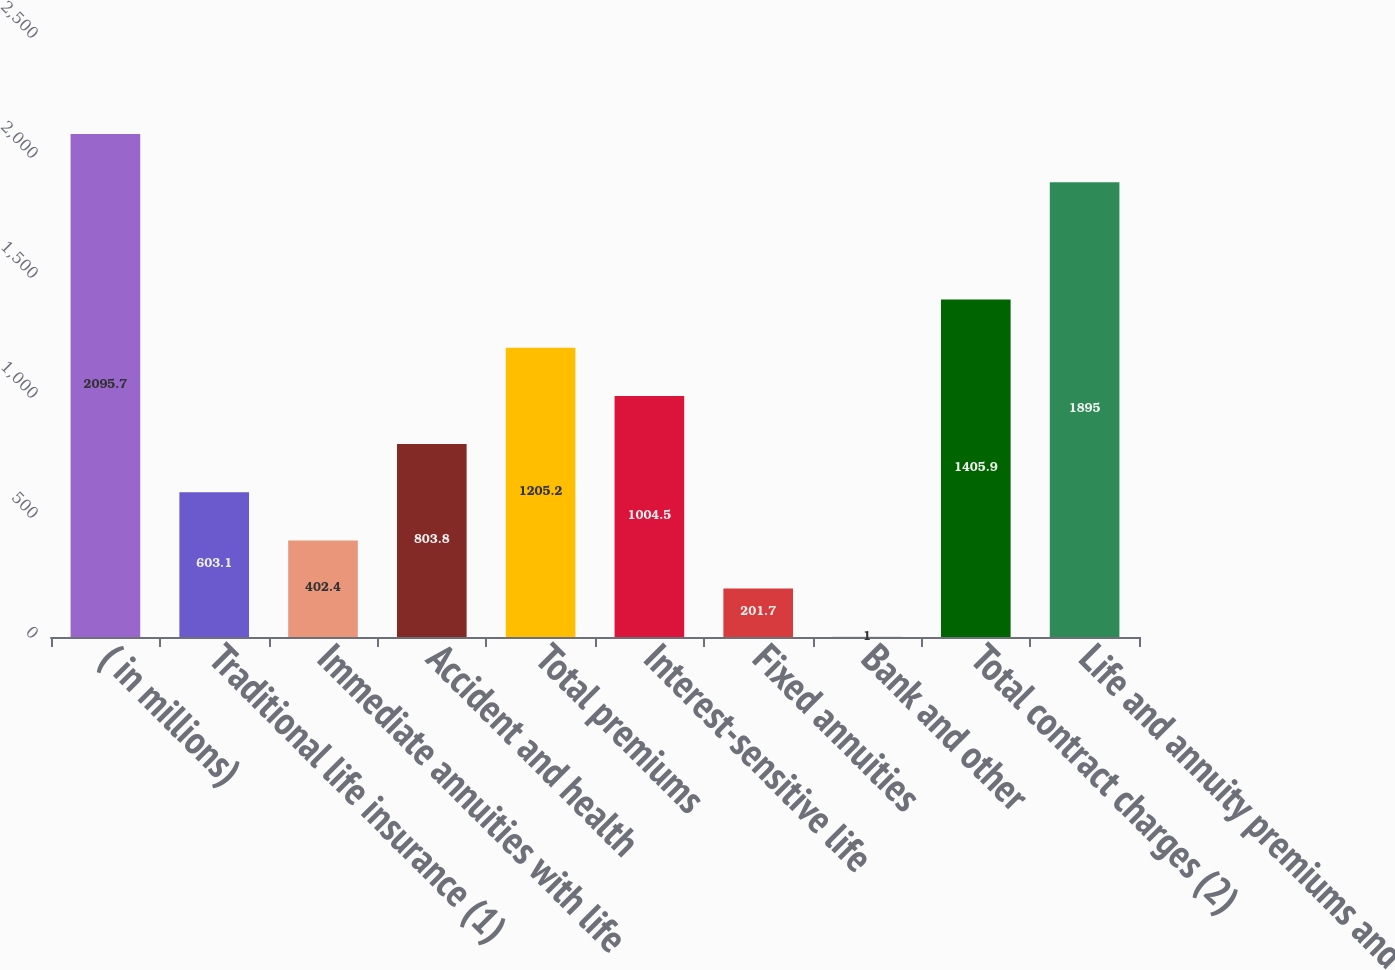Convert chart to OTSL. <chart><loc_0><loc_0><loc_500><loc_500><bar_chart><fcel>( in millions)<fcel>Traditional life insurance (1)<fcel>Immediate annuities with life<fcel>Accident and health<fcel>Total premiums<fcel>Interest-sensitive life<fcel>Fixed annuities<fcel>Bank and other<fcel>Total contract charges (2)<fcel>Life and annuity premiums and<nl><fcel>2095.7<fcel>603.1<fcel>402.4<fcel>803.8<fcel>1205.2<fcel>1004.5<fcel>201.7<fcel>1<fcel>1405.9<fcel>1895<nl></chart> 